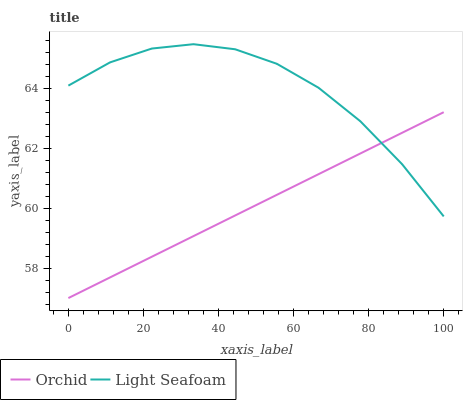Does Orchid have the minimum area under the curve?
Answer yes or no. Yes. Does Light Seafoam have the maximum area under the curve?
Answer yes or no. Yes. Does Orchid have the maximum area under the curve?
Answer yes or no. No. Is Orchid the smoothest?
Answer yes or no. Yes. Is Light Seafoam the roughest?
Answer yes or no. Yes. Is Orchid the roughest?
Answer yes or no. No. Does Light Seafoam have the highest value?
Answer yes or no. Yes. Does Orchid have the highest value?
Answer yes or no. No. Does Orchid intersect Light Seafoam?
Answer yes or no. Yes. Is Orchid less than Light Seafoam?
Answer yes or no. No. Is Orchid greater than Light Seafoam?
Answer yes or no. No. 